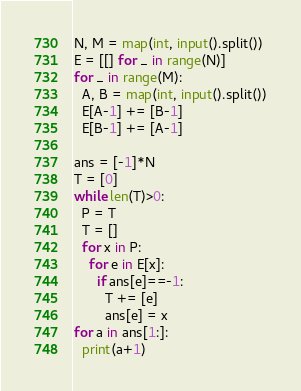<code> <loc_0><loc_0><loc_500><loc_500><_Python_>N, M = map(int, input().split())
E = [[] for _ in range(N)]
for _ in range(M):
  A, B = map(int, input().split())
  E[A-1] += [B-1]
  E[B-1] += [A-1]

ans = [-1]*N
T = [0]
while len(T)>0:
  P = T
  T = []
  for x in P:
    for e in E[x]:
      if ans[e]==-1:
        T += [e]
        ans[e] = x
for a in ans[1:]:
  print(a+1)
</code> 